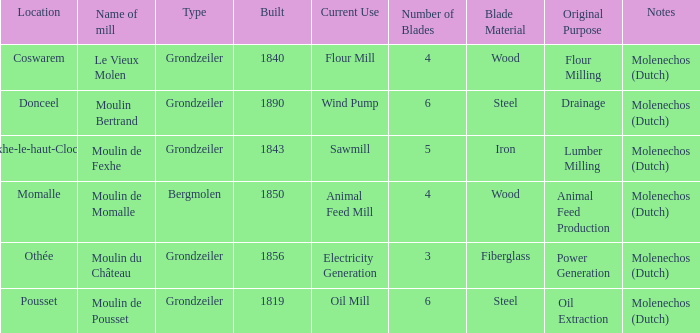What is the Name of the Grondzeiler Mill? Le Vieux Molen, Moulin Bertrand, Moulin de Fexhe, Moulin du Château, Moulin de Pousset. 